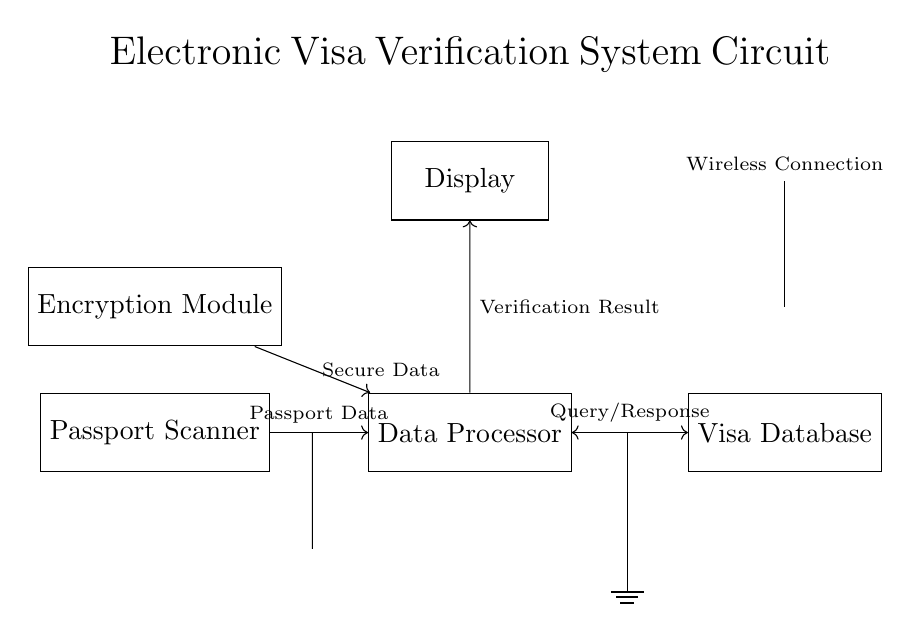What are the main components of the circuit? The circuit consists of a passport scanner, data processor, visa database, display, encryption module, and an antenna for wireless communication.
Answer: Passport Scanner, Data Processor, Visa Database, Display, Encryption Module, Antenna What type of connection does the processor have with the database? The processor communicates with the database using a bidirectional connection allowing for query and response messages. This is indicated by the double-headed arrow between them.
Answer: Query/Response How does the passport data flow in the circuit? Passport data flows from the passport scanner to the data processor, which processes the data and communicates with the visa database. This flow is shown by the arrows directing the data from the scanner to the processor.
Answer: Scanner to Processor What is the purpose of the encryption module in the circuit? The encryption module secures the data being sent to the processor, indicating that security is a priority in the visa verification process. This is illustrated by the connection from the encryption module to the data processor labeled "Secure Data."
Answer: Secure Data What is the function of the display in the circuit? The display shows the verification result after the data processor has processed the passport data and received a response from the visa database. This is derived from the arrow pointing from the processor to the display labeled "Verification Result."
Answer: Verification Result 